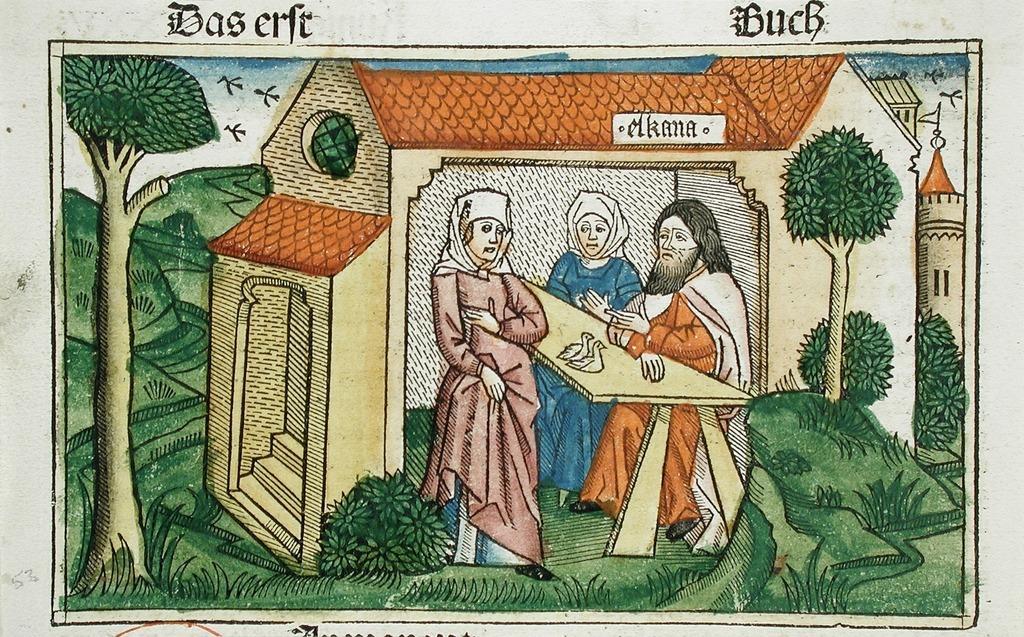In one or two sentences, can you explain what this image depicts? In this image there is a painting of a few people and two birds on the table, behind them there is a house, around the house there is greenery with trees, plants and grass. In the background there are a few birds in the sky, at the top and bottom of the image there is some text. 